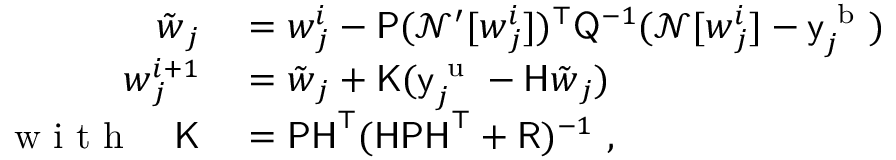<formula> <loc_0><loc_0><loc_500><loc_500>\begin{array} { r l } { \tilde { w } _ { j } } & = w _ { j } ^ { i } - P ( \mathcal { N } ^ { \prime } [ w _ { j } ^ { i } ] ) ^ { \top } Q ^ { - 1 } ( \mathcal { N } [ w _ { j } ^ { i } ] - y _ { j } ^ { b } ) } \\ { w _ { j } ^ { i + 1 } } & = \tilde { w } _ { j } + K ( y _ { j } ^ { u } - H \tilde { w } _ { j } ) } \\ { w i t h \quad K } & = P H ^ { \top } ( H P H ^ { \top } + R ) ^ { - 1 } , } \end{array}</formula> 